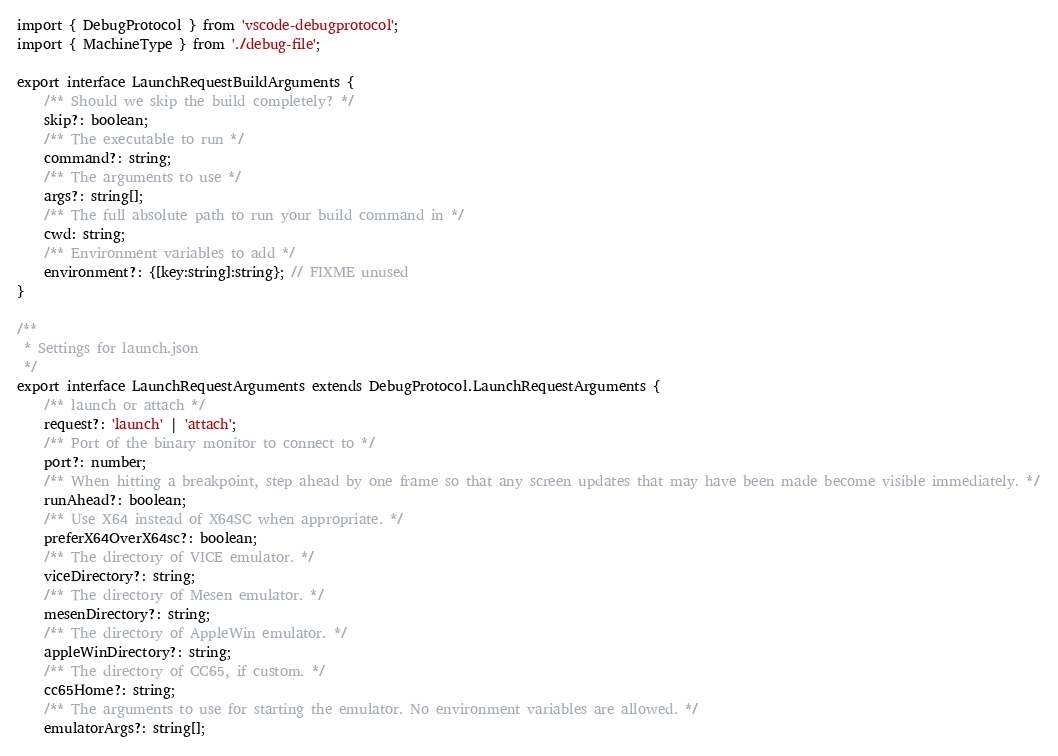<code> <loc_0><loc_0><loc_500><loc_500><_TypeScript_>import { DebugProtocol } from 'vscode-debugprotocol';
import { MachineType } from './debug-file';

export interface LaunchRequestBuildArguments {
    /** Should we skip the build completely? */
    skip?: boolean;
    /** The executable to run */
    command?: string;
    /** The arguments to use */
    args?: string[];
    /** The full absolute path to run your build command in */
    cwd: string;
    /** Environment variables to add */
    environment?: {[key:string]:string}; // FIXME unused
}

/**
 * Settings for launch.json
 */
export interface LaunchRequestArguments extends DebugProtocol.LaunchRequestArguments {
    /** launch or attach */
    request?: 'launch' | 'attach';
    /** Port of the binary monitor to connect to */
    port?: number;
    /** When hitting a breakpoint, step ahead by one frame so that any screen updates that may have been made become visible immediately. */
    runAhead?: boolean;
    /** Use X64 instead of X64SC when appropriate. */
    preferX64OverX64sc?: boolean;
    /** The directory of VICE emulator. */
    viceDirectory?: string;
    /** The directory of Mesen emulator. */
    mesenDirectory?: string;
    /** The directory of AppleWin emulator. */
    appleWinDirectory?: string;
    /** The directory of CC65, if custom. */
    cc65Home?: string;
    /** The arguments to use for starting the emulator. No environment variables are allowed. */
    emulatorArgs?: string[];</code> 